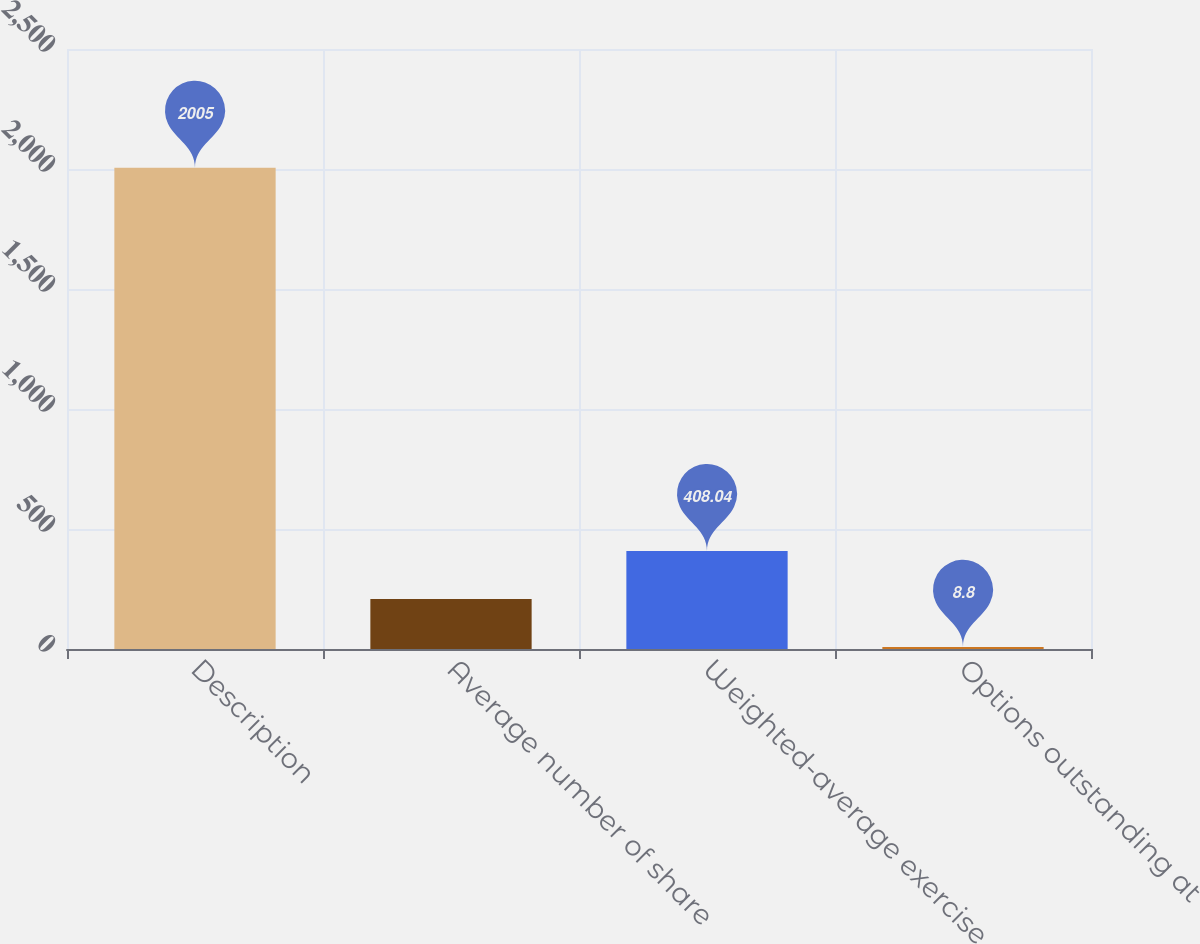<chart> <loc_0><loc_0><loc_500><loc_500><bar_chart><fcel>Description<fcel>Average number of share<fcel>Weighted-average exercise<fcel>Options outstanding at<nl><fcel>2005<fcel>208.42<fcel>408.04<fcel>8.8<nl></chart> 